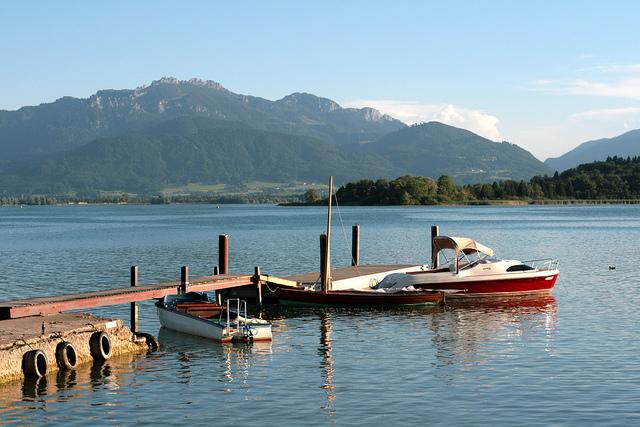How many tires are used a bumpers on the dock?
Answer briefly. 3. How many boats are there?
Give a very brief answer. 2. two. Three tires are shown in this picture?
Give a very brief answer. Yes. 